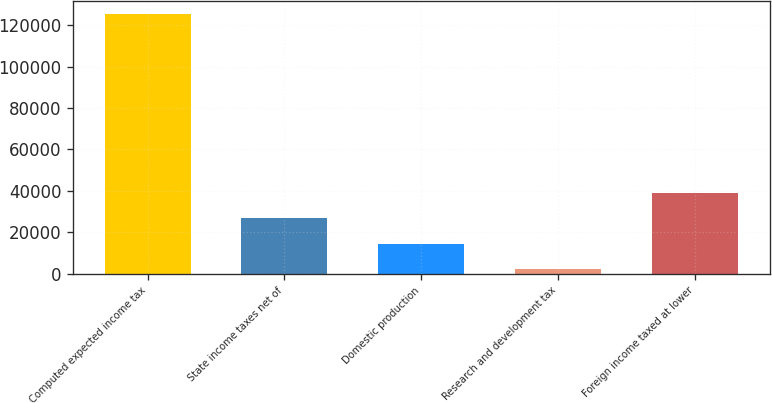<chart> <loc_0><loc_0><loc_500><loc_500><bar_chart><fcel>Computed expected income tax<fcel>State income taxes net of<fcel>Domestic production<fcel>Research and development tax<fcel>Foreign income taxed at lower<nl><fcel>125715<fcel>26819<fcel>14457<fcel>2095<fcel>39181<nl></chart> 